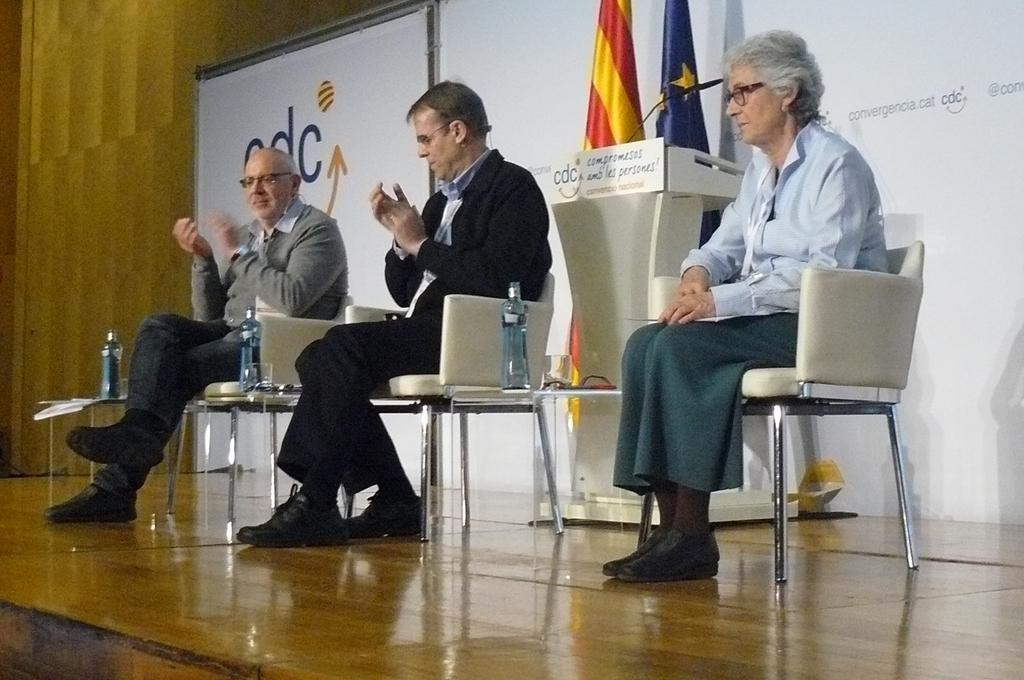How many people are in the image? There are two men and one woman in the image. What are the individuals doing in the image? They are seated on chairs and clapping their hands. What objects can be seen near the individuals? There are water bottles visible in the image. What is located in front of the individuals? There is a podium with a microphone in the image. How many flags are present in the image? Two flags are present in the image. What type of nerve can be seen in the image? There is no nerve visible in the image. Is there a kettle present in the image? There is no kettle present in the image. 